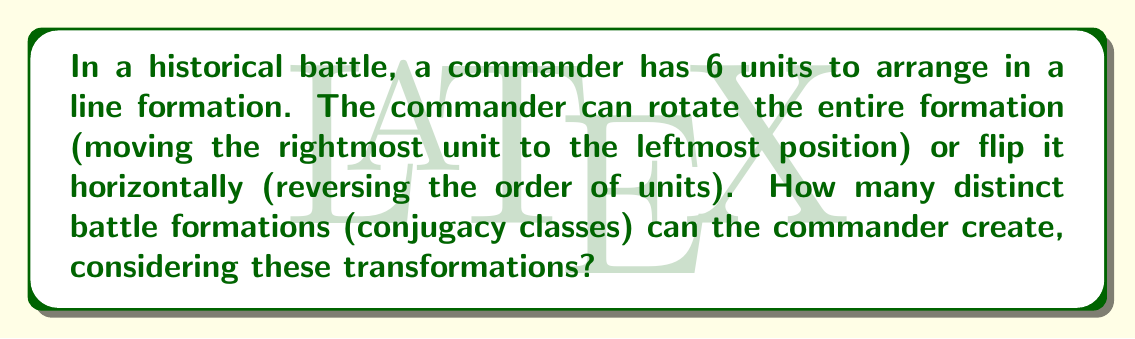What is the answer to this math problem? To solve this problem, we need to use concepts from group theory, particularly the idea of conjugacy classes in the dihedral group $D_6$.

1) First, we recognize that the possible arrangements of 6 units in a line, with rotations and flips allowed, form the dihedral group $D_6$.

2) The number of conjugacy classes in $D_6$ is equal to the number of distinct battle formations.

3) In $D_6$, there are three types of elements:
   a) The identity element (1)
   b) Rotations (5 non-identity rotations)
   c) Reflections (6 reflections)

4) To find the number of conjugacy classes, we need to determine how these elements are grouped:
   a) The identity is always in its own conjugacy class.
   b) For rotations:
      - Rotations by 60° and 300° form one class
      - Rotations by 120° and 240° form another class
      - Rotation by 180° is in its own class
   c) For reflections:
      - All 6 reflections form a single conjugacy class

5) Counting the classes:
   - Identity: 1 class
   - Rotations: 3 classes
   - Reflections: 1 class

6) Therefore, the total number of conjugacy classes (distinct battle formations) is 1 + 3 + 1 = 5.

This result shows that despite having 6! = 720 possible permutations of 6 units, the symmetries of rotation and reflection reduce the number of truly distinct formations to just 5.
Answer: 5 conjugacy classes (distinct battle formations) 